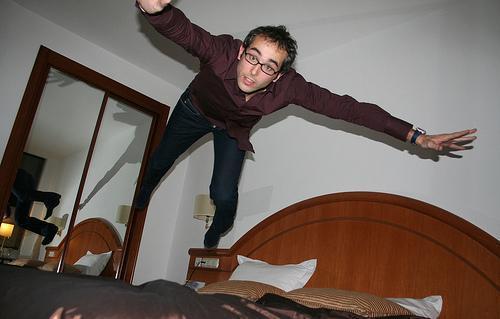How many people are in the picture?
Give a very brief answer. 1. 